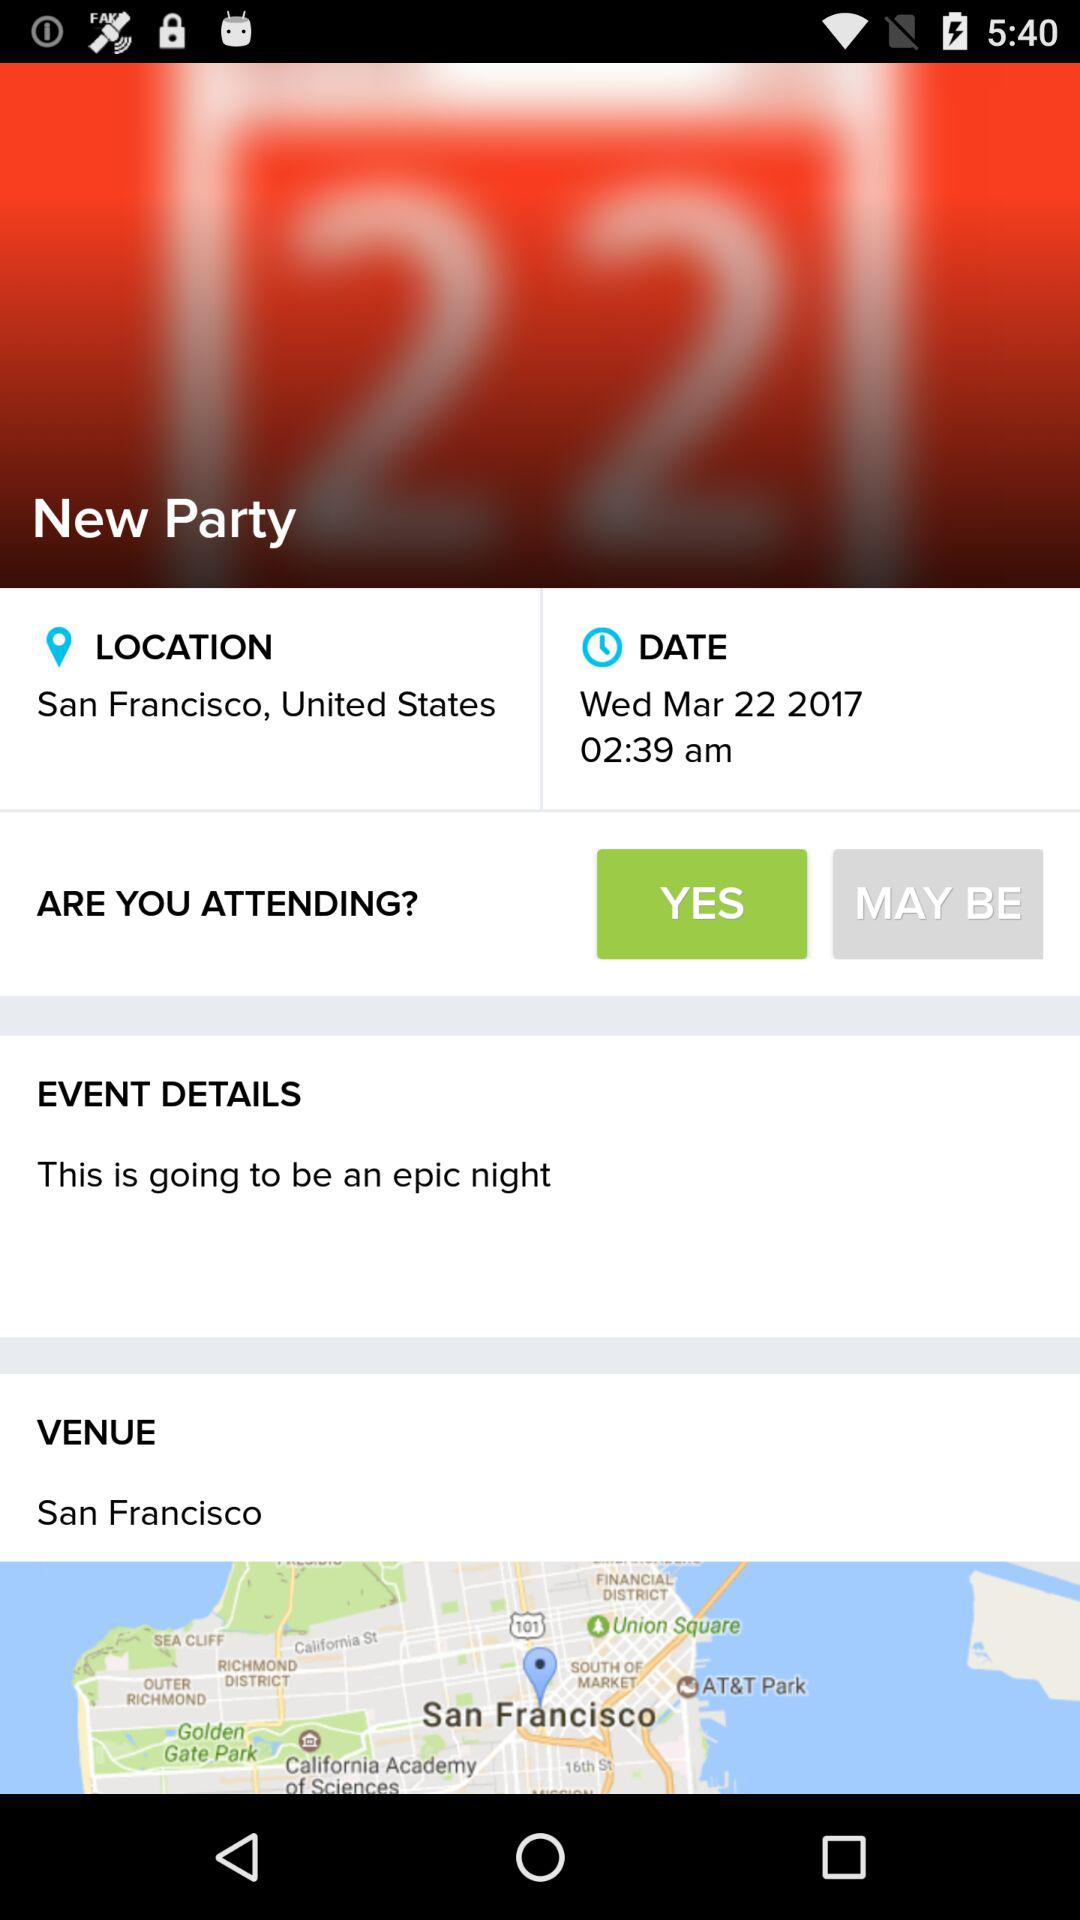What is the time? The time is 2:39 a.m. 